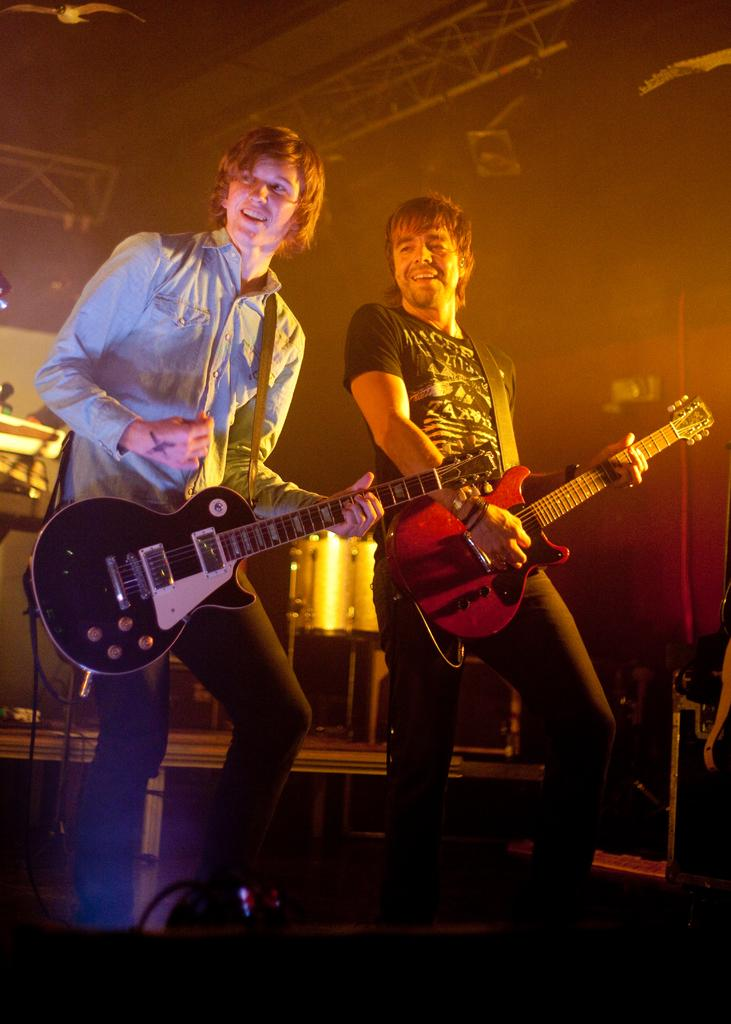How many people are in the image? There are two people in the image. What are the two people doing? The two people are standing and playing guitar. Is there any musical instrument visible in the image besides the guitars? Yes, there is a drum visible in the background. What type of setting is depicted in the image? The scene appears to be a stage show. What type of design can be seen on the cannon in the image? There is no cannon present in the image. How does the land appear in the image? The image does not show any land; it focuses on the two people playing guitar and the drum in the background. 